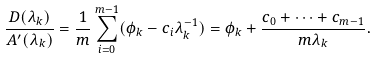Convert formula to latex. <formula><loc_0><loc_0><loc_500><loc_500>\frac { D ( \lambda _ { k } ) } { A ^ { \prime } ( \lambda _ { k } ) } = \frac { 1 } { m } \sum _ { i = 0 } ^ { m - 1 } ( \phi _ { k } - c _ { i } \lambda _ { k } ^ { - 1 } ) = \phi _ { k } + \frac { c _ { 0 } + \dots + c _ { m - 1 } } { m \lambda _ { k } } .</formula> 